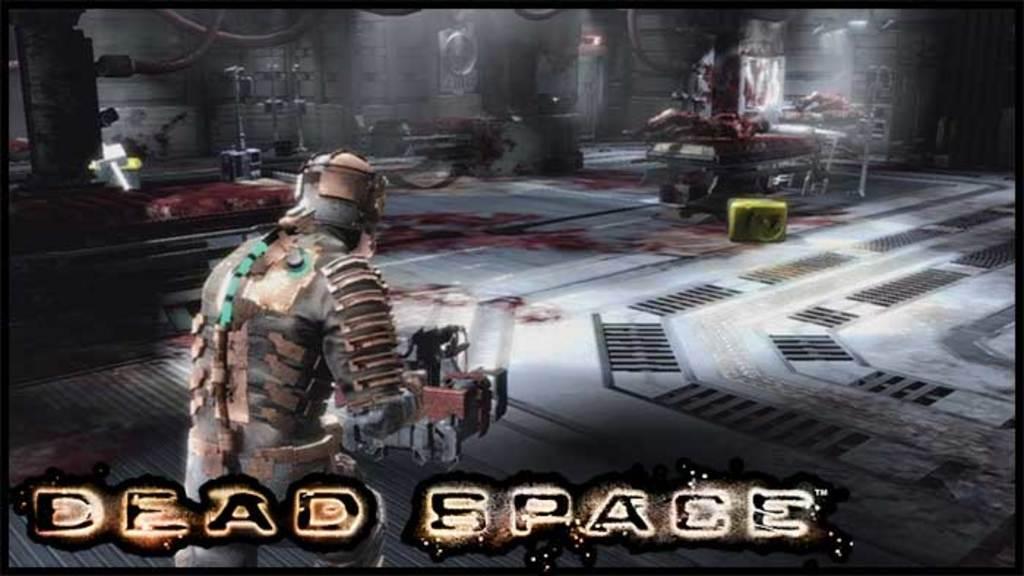Can you describe this image briefly? This is a screen of a game, on the left side there is a man with a weapon in his hand, in the front there are beds and machineries. 